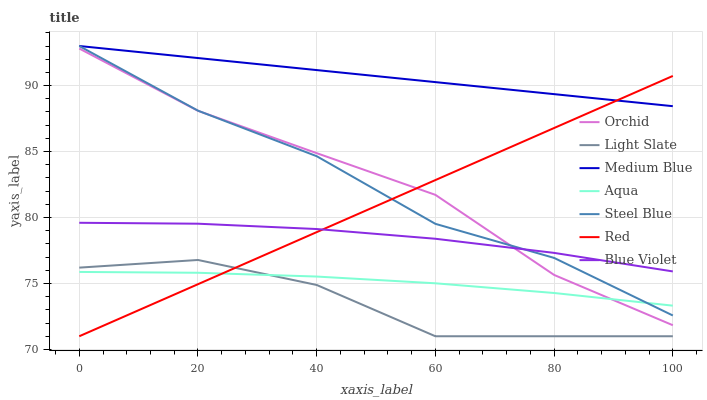Does Light Slate have the minimum area under the curve?
Answer yes or no. Yes. Does Medium Blue have the maximum area under the curve?
Answer yes or no. Yes. Does Aqua have the minimum area under the curve?
Answer yes or no. No. Does Aqua have the maximum area under the curve?
Answer yes or no. No. Is Medium Blue the smoothest?
Answer yes or no. Yes. Is Light Slate the roughest?
Answer yes or no. Yes. Is Aqua the smoothest?
Answer yes or no. No. Is Aqua the roughest?
Answer yes or no. No. Does Light Slate have the lowest value?
Answer yes or no. Yes. Does Aqua have the lowest value?
Answer yes or no. No. Does Steel Blue have the highest value?
Answer yes or no. Yes. Does Aqua have the highest value?
Answer yes or no. No. Is Orchid less than Medium Blue?
Answer yes or no. Yes. Is Medium Blue greater than Blue Violet?
Answer yes or no. Yes. Does Orchid intersect Aqua?
Answer yes or no. Yes. Is Orchid less than Aqua?
Answer yes or no. No. Is Orchid greater than Aqua?
Answer yes or no. No. Does Orchid intersect Medium Blue?
Answer yes or no. No. 